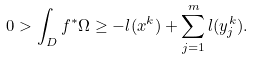Convert formula to latex. <formula><loc_0><loc_0><loc_500><loc_500>0 > \int _ { D } f ^ { * } \Omega \geq - l ( x ^ { k } ) + \sum _ { j = 1 } ^ { m } l ( y _ { j } ^ { k } ) .</formula> 